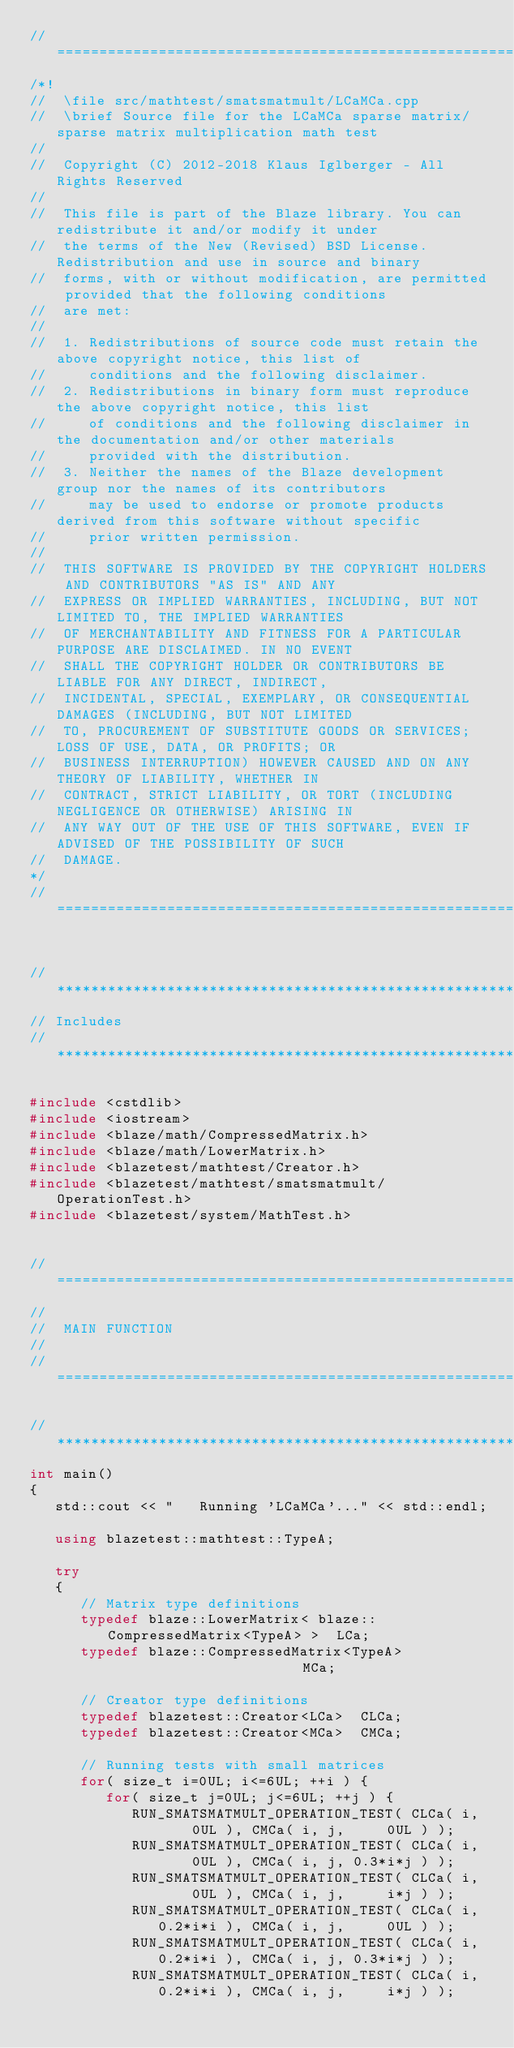Convert code to text. <code><loc_0><loc_0><loc_500><loc_500><_C++_>//=================================================================================================
/*!
//  \file src/mathtest/smatsmatmult/LCaMCa.cpp
//  \brief Source file for the LCaMCa sparse matrix/sparse matrix multiplication math test
//
//  Copyright (C) 2012-2018 Klaus Iglberger - All Rights Reserved
//
//  This file is part of the Blaze library. You can redistribute it and/or modify it under
//  the terms of the New (Revised) BSD License. Redistribution and use in source and binary
//  forms, with or without modification, are permitted provided that the following conditions
//  are met:
//
//  1. Redistributions of source code must retain the above copyright notice, this list of
//     conditions and the following disclaimer.
//  2. Redistributions in binary form must reproduce the above copyright notice, this list
//     of conditions and the following disclaimer in the documentation and/or other materials
//     provided with the distribution.
//  3. Neither the names of the Blaze development group nor the names of its contributors
//     may be used to endorse or promote products derived from this software without specific
//     prior written permission.
//
//  THIS SOFTWARE IS PROVIDED BY THE COPYRIGHT HOLDERS AND CONTRIBUTORS "AS IS" AND ANY
//  EXPRESS OR IMPLIED WARRANTIES, INCLUDING, BUT NOT LIMITED TO, THE IMPLIED WARRANTIES
//  OF MERCHANTABILITY AND FITNESS FOR A PARTICULAR PURPOSE ARE DISCLAIMED. IN NO EVENT
//  SHALL THE COPYRIGHT HOLDER OR CONTRIBUTORS BE LIABLE FOR ANY DIRECT, INDIRECT,
//  INCIDENTAL, SPECIAL, EXEMPLARY, OR CONSEQUENTIAL DAMAGES (INCLUDING, BUT NOT LIMITED
//  TO, PROCUREMENT OF SUBSTITUTE GOODS OR SERVICES; LOSS OF USE, DATA, OR PROFITS; OR
//  BUSINESS INTERRUPTION) HOWEVER CAUSED AND ON ANY THEORY OF LIABILITY, WHETHER IN
//  CONTRACT, STRICT LIABILITY, OR TORT (INCLUDING NEGLIGENCE OR OTHERWISE) ARISING IN
//  ANY WAY OUT OF THE USE OF THIS SOFTWARE, EVEN IF ADVISED OF THE POSSIBILITY OF SUCH
//  DAMAGE.
*/
//=================================================================================================


//*************************************************************************************************
// Includes
//*************************************************************************************************

#include <cstdlib>
#include <iostream>
#include <blaze/math/CompressedMatrix.h>
#include <blaze/math/LowerMatrix.h>
#include <blazetest/mathtest/Creator.h>
#include <blazetest/mathtest/smatsmatmult/OperationTest.h>
#include <blazetest/system/MathTest.h>


//=================================================================================================
//
//  MAIN FUNCTION
//
//=================================================================================================

//*************************************************************************************************
int main()
{
   std::cout << "   Running 'LCaMCa'..." << std::endl;

   using blazetest::mathtest::TypeA;

   try
   {
      // Matrix type definitions
      typedef blaze::LowerMatrix< blaze::CompressedMatrix<TypeA> >  LCa;
      typedef blaze::CompressedMatrix<TypeA>                        MCa;

      // Creator type definitions
      typedef blazetest::Creator<LCa>  CLCa;
      typedef blazetest::Creator<MCa>  CMCa;

      // Running tests with small matrices
      for( size_t i=0UL; i<=6UL; ++i ) {
         for( size_t j=0UL; j<=6UL; ++j ) {
            RUN_SMATSMATMULT_OPERATION_TEST( CLCa( i,     0UL ), CMCa( i, j,     0UL ) );
            RUN_SMATSMATMULT_OPERATION_TEST( CLCa( i,     0UL ), CMCa( i, j, 0.3*i*j ) );
            RUN_SMATSMATMULT_OPERATION_TEST( CLCa( i,     0UL ), CMCa( i, j,     i*j ) );
            RUN_SMATSMATMULT_OPERATION_TEST( CLCa( i, 0.2*i*i ), CMCa( i, j,     0UL ) );
            RUN_SMATSMATMULT_OPERATION_TEST( CLCa( i, 0.2*i*i ), CMCa( i, j, 0.3*i*j ) );
            RUN_SMATSMATMULT_OPERATION_TEST( CLCa( i, 0.2*i*i ), CMCa( i, j,     i*j ) );</code> 